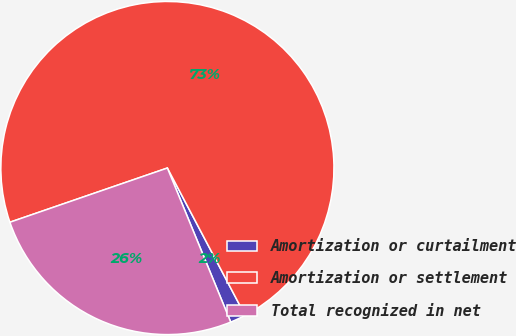Convert chart. <chart><loc_0><loc_0><loc_500><loc_500><pie_chart><fcel>Amortization or curtailment<fcel>Amortization or settlement<fcel>Total recognized in net<nl><fcel>1.52%<fcel>72.55%<fcel>25.93%<nl></chart> 